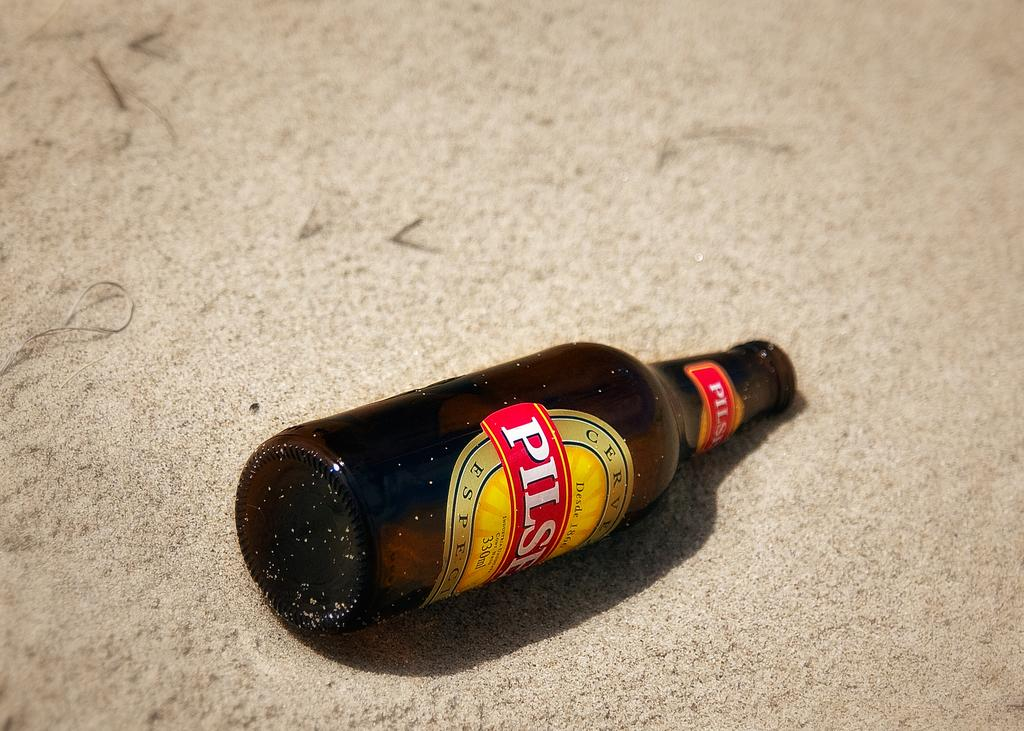Provide a one-sentence caption for the provided image. A bottle of Pilser beer lays in the sand. 